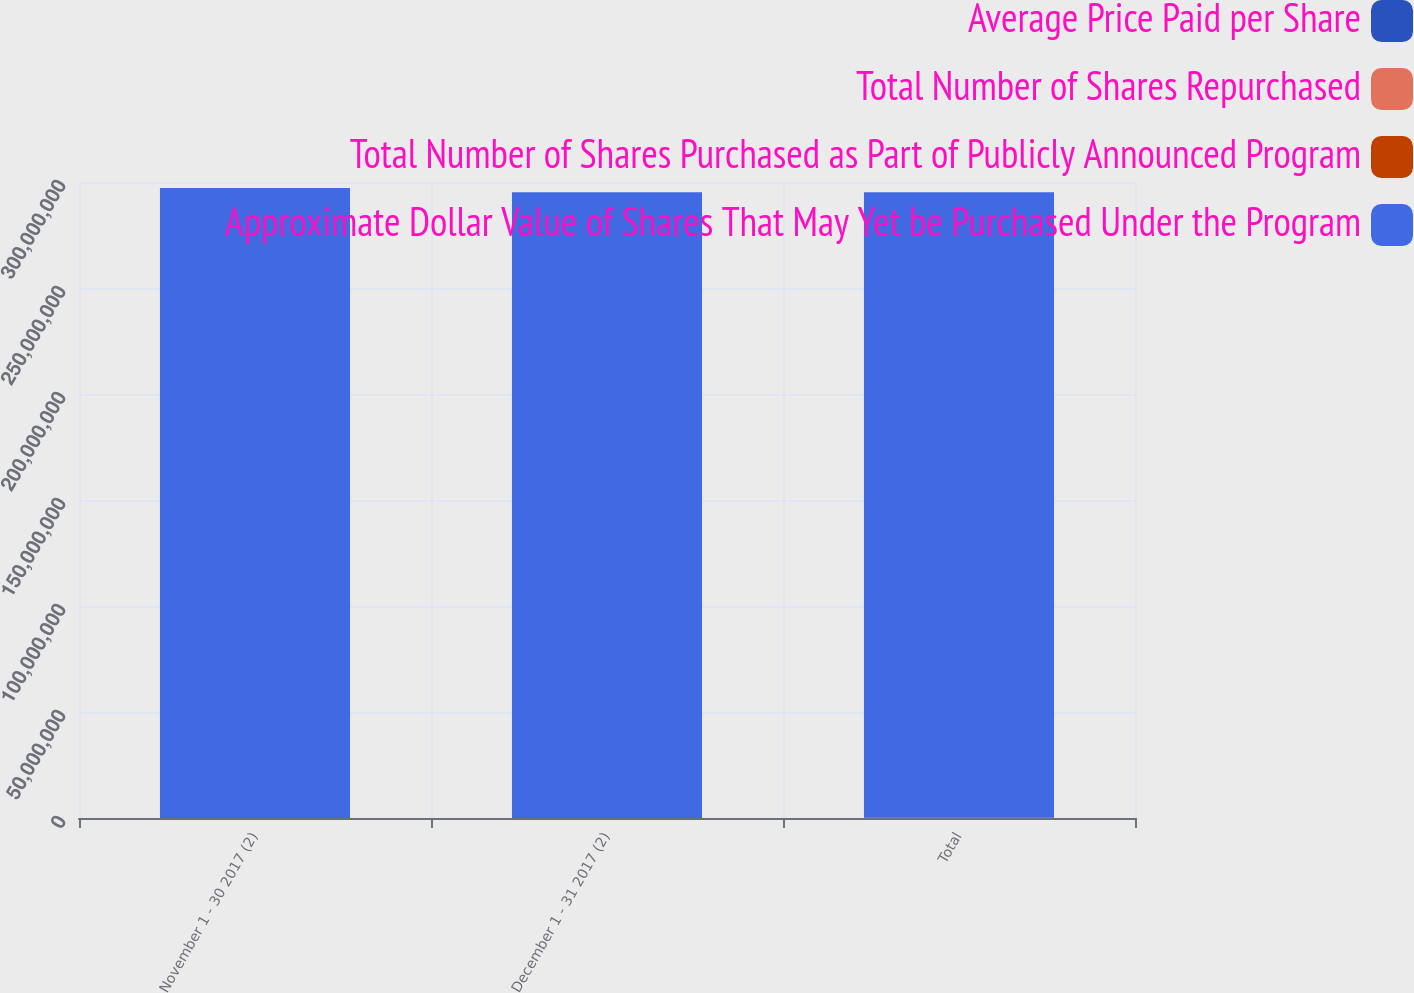<chart> <loc_0><loc_0><loc_500><loc_500><stacked_bar_chart><ecel><fcel>November 1 - 30 2017 (2)<fcel>December 1 - 31 2017 (2)<fcel>Total<nl><fcel>Average Price Paid per Share<fcel>19144<fcel>12901<fcel>32045<nl><fcel>Total Number of Shares Repurchased<fcel>150.4<fcel>153.42<fcel>151.61<nl><fcel>Total Number of Shares Purchased as Part of Publicly Announced Program<fcel>19144<fcel>12901<fcel>32045<nl><fcel>Approximate Dollar Value of Shares That May Yet be Purchased Under the Program<fcel>2.97121e+08<fcel>2.95141e+08<fcel>2.95141e+08<nl></chart> 